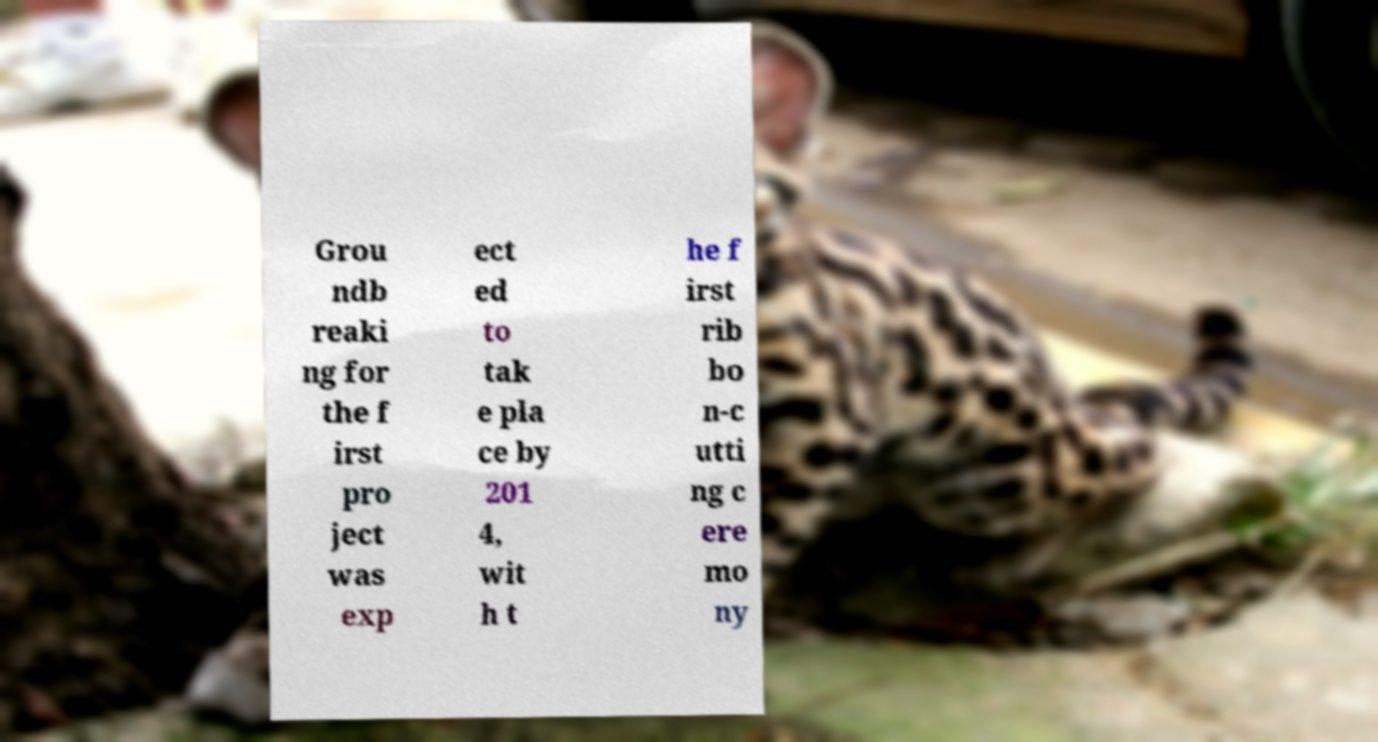What messages or text are displayed in this image? I need them in a readable, typed format. Grou ndb reaki ng for the f irst pro ject was exp ect ed to tak e pla ce by 201 4, wit h t he f irst rib bo n-c utti ng c ere mo ny 